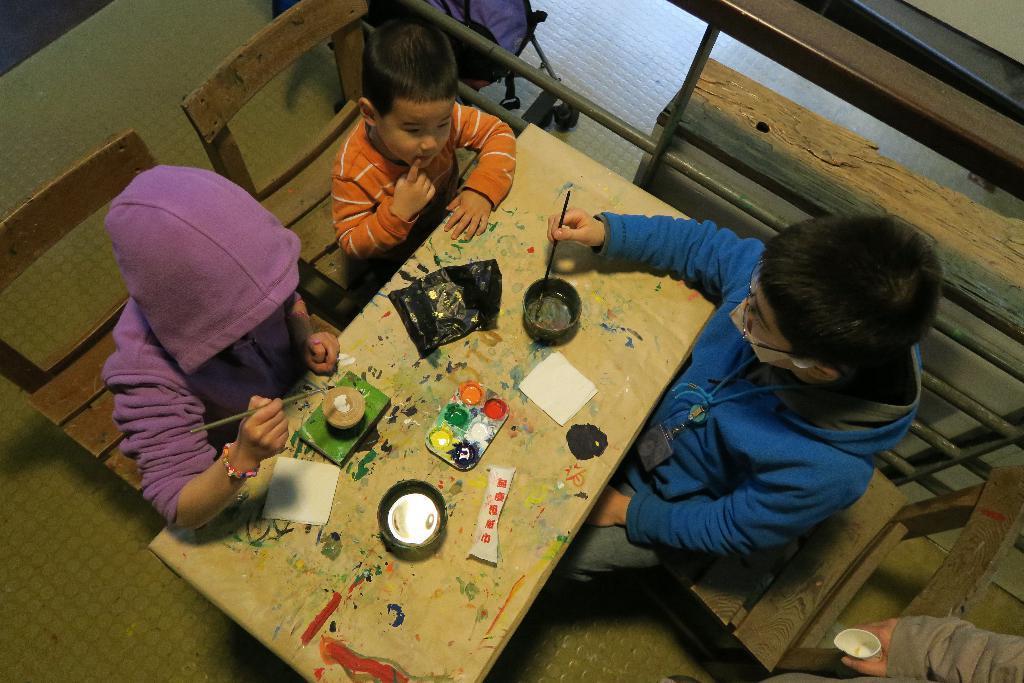Can you describe this image briefly? In this image I can see few children wearing blue, orange and purple colored dresses are sitting on chairs in front of a table and on the table I can see few cups, few paints, few papers and few other objects. I can see they are holding paint brushes in their hands. To the right bottom of the image I can see a hand of a person. 